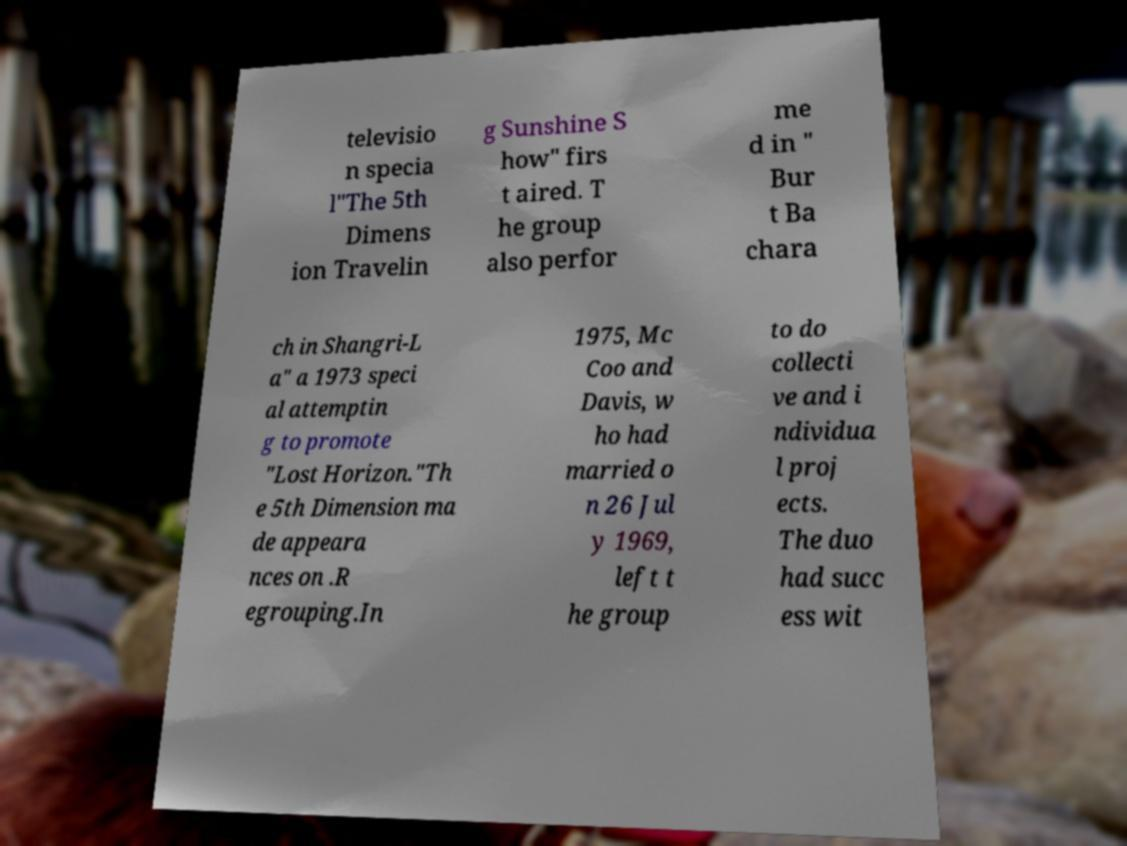Please identify and transcribe the text found in this image. televisio n specia l"The 5th Dimens ion Travelin g Sunshine S how" firs t aired. T he group also perfor me d in " Bur t Ba chara ch in Shangri-L a" a 1973 speci al attemptin g to promote "Lost Horizon."Th e 5th Dimension ma de appeara nces on .R egrouping.In 1975, Mc Coo and Davis, w ho had married o n 26 Jul y 1969, left t he group to do collecti ve and i ndividua l proj ects. The duo had succ ess wit 